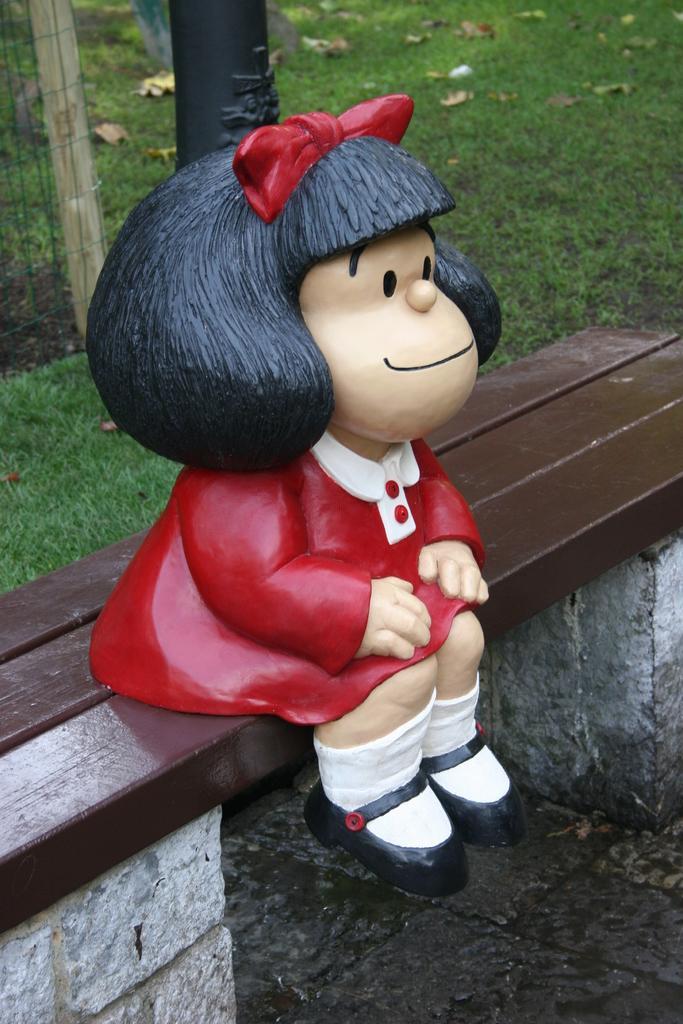In one or two sentences, can you explain what this image depicts? In the center of picture there is a toy which is on a bench. At the top there are dry leaves, grass and fencing. 